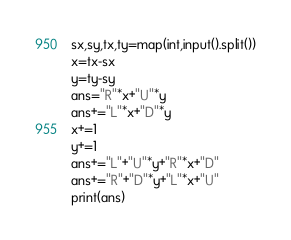<code> <loc_0><loc_0><loc_500><loc_500><_Python_>sx,sy,tx,ty=map(int,input().split())
x=tx-sx
y=ty-sy
ans="R"*x+"U"*y
ans+="L"*x+"D"*y
x+=1
y+=1
ans+="L"+"U"*y+"R"*x+"D"
ans+="R"+"D"*y+"L"*x+"U"
print(ans)</code> 